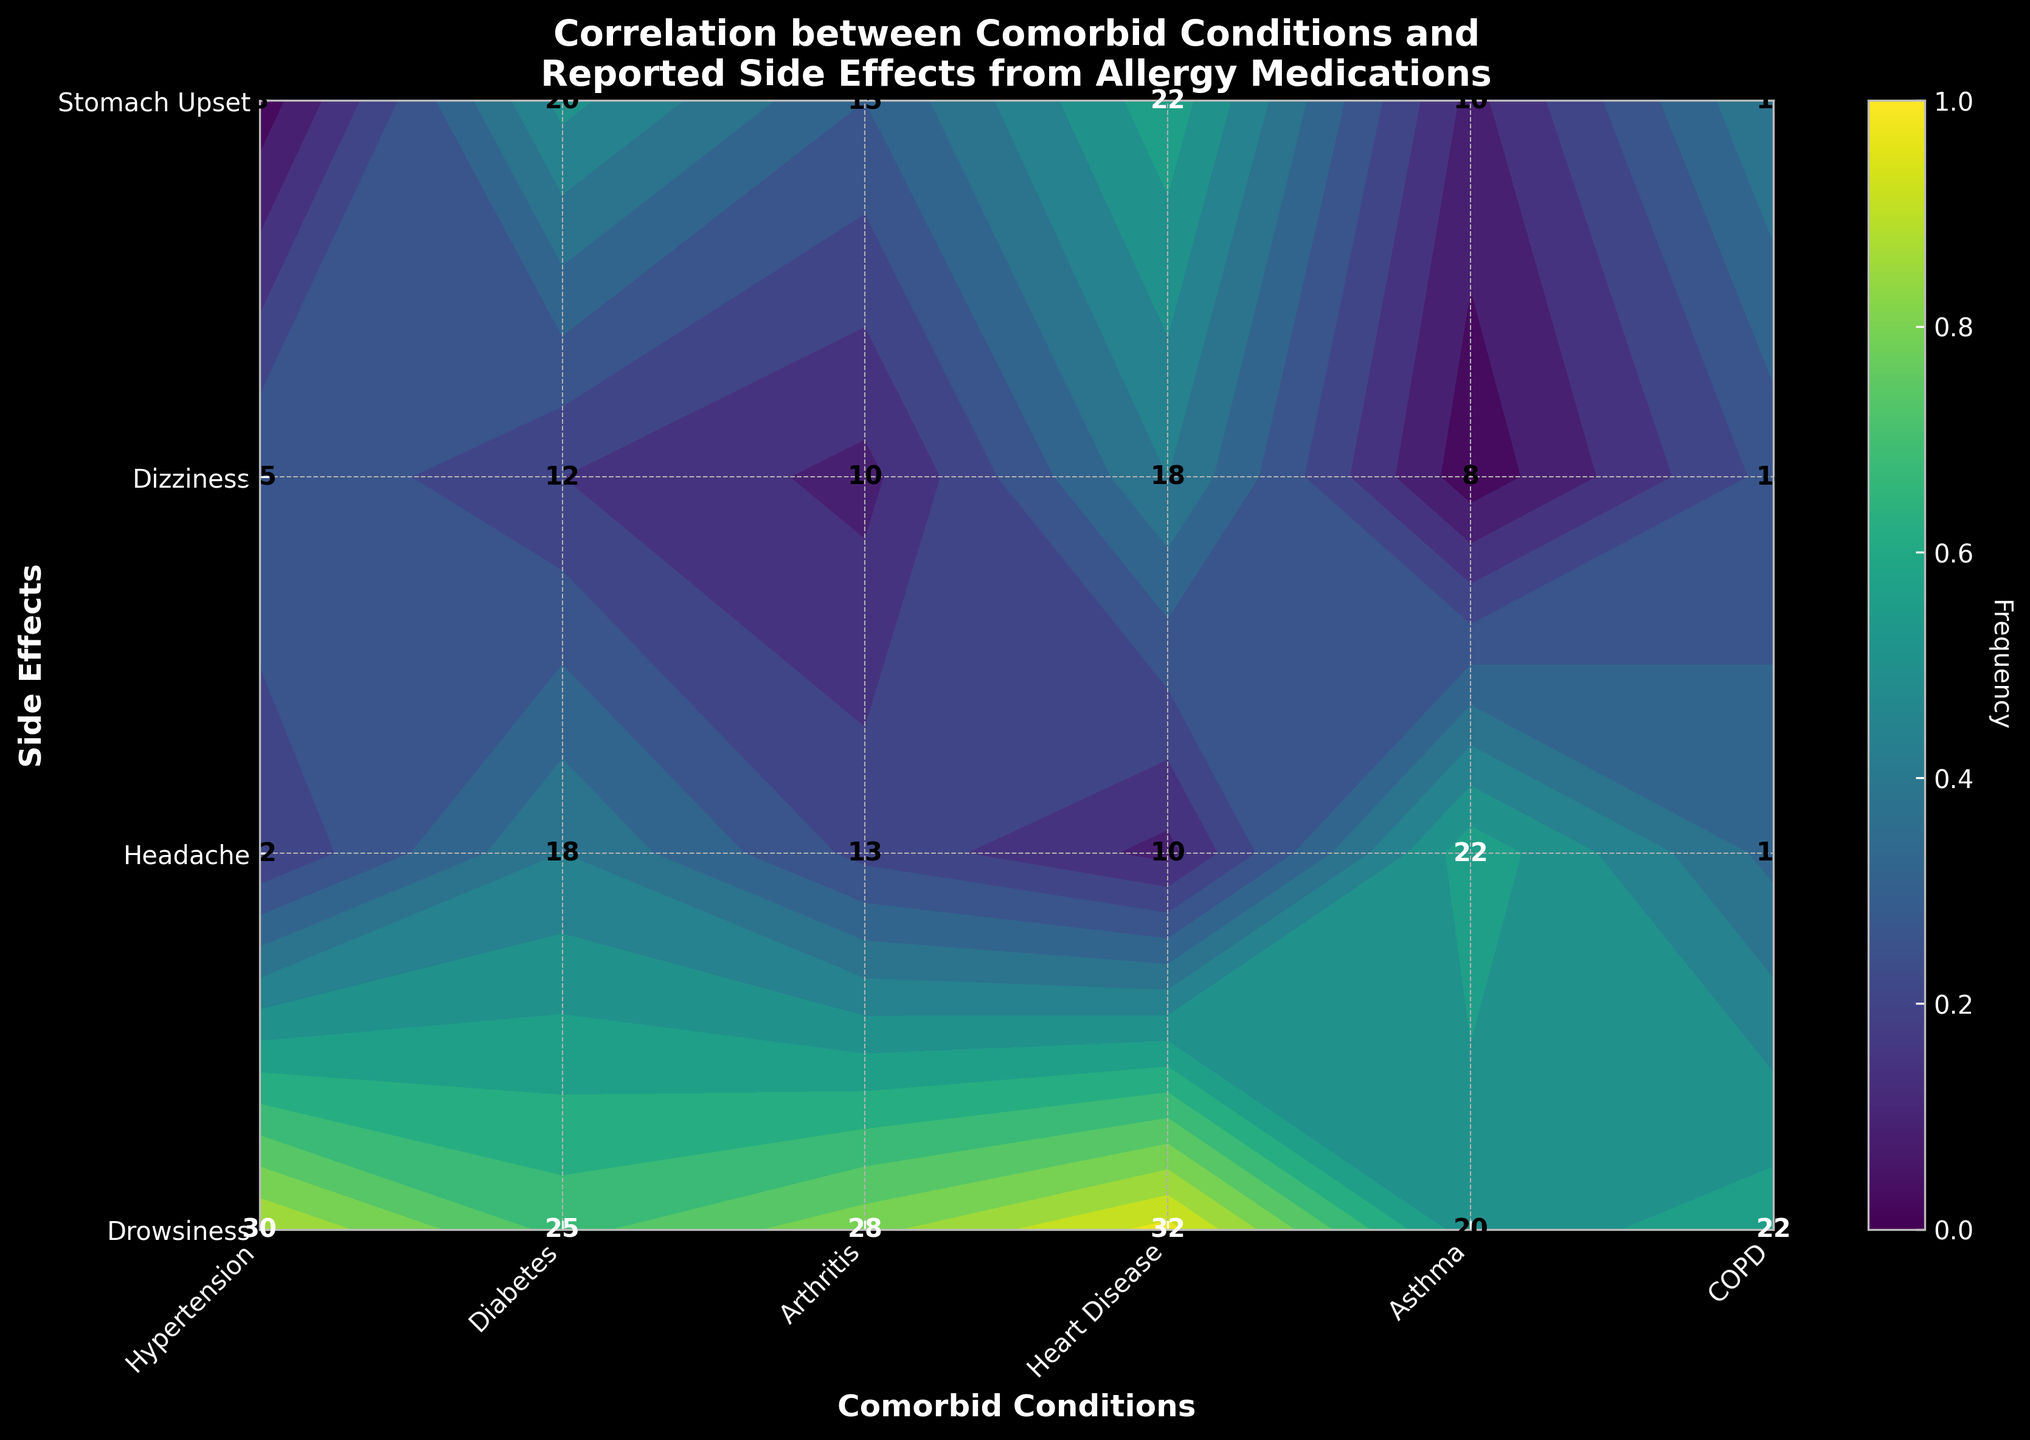What's the title of the plot? The title is usually located at the top of the plot. By reading it, we can understand the main subject of the plot.
Answer: Correlation between Comorbid Conditions and Reported Side Effects from Allergy Medications What side effect has the highest frequency for people with heart disease? To determine this, find the column for "Heart Disease" and look for the highest value in that column.
Answer: Drowsiness How many side effects are analyzed in this plot? Count the number of unique side effects listed on the y-axis.
Answer: 4 Which side effect has the lowest frequency for diabetes? Look at the column for "Diabetes" and identify the smallest value.
Answer: Dizziness Are there any conditions for which stomach upset is reported more frequently than Dizziness? Compare the values for stomach upset and dizziness across all comorbid conditions.
Answer: Yes What is the average frequency of reported side effects for asthma? Add the frequencies of all the side effects for asthma and divide by the number of side effects.
Answer: 15 How does the frequency of drowsiness for people with COPD compare to those with diabetes? Compare the frequency of drowsiness for COPD and diabetes in their respective columns.
Answer: Higher for COPD Which combination of condition and side effect has the highest frequency overall? Look for the highest value in the entire plot and note the corresponding condition and side effect.
Answer: Heart Disease and Drowsiness Is there any condition where headache is reported more frequently than drowsiness? Compare the values for each condition in the headache and drowsiness rows.
Answer: No How does the frequency of stomach upset for arthritis compare to that for heart disease? Compare the values for stomach upset in the columns for arthritis and heart disease.
Answer: Lower for Arthritis 